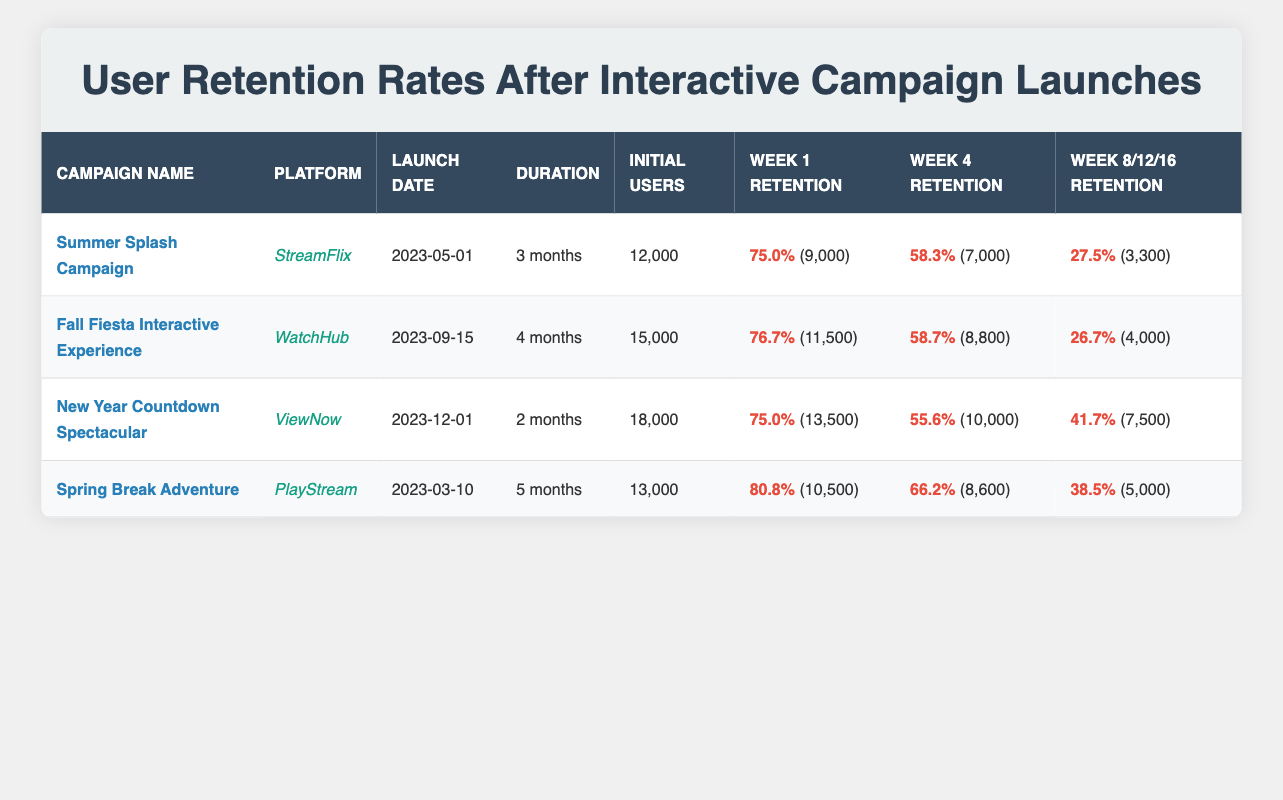What is the retention rate of the Summer Splash Campaign in Week 1? The retention rate for the Summer Splash Campaign in Week 1 is found in the corresponding column and row of the table. It specifically states 75.0%.
Answer: 75.0% How many initial users participated in the Fall Fiesta Interactive Experience? The initial users for the Fall Fiesta Interactive Experience are listed in the 'Initial Users' column, which shows 15,000 users.
Answer: 15,000 What is the difference in Week 4 retention rates between the Spring Break Adventure and the New Year Countdown Spectacular campaigns? The Week 4 retention rate for the Spring Break Adventure is 66.2%, while for the New Year Countdown Spectacular, it is 55.6%. The difference is calculated by subtracting the latter from the former: 66.2% - 55.6% = 10.6%.
Answer: 10.6% Is the retention rate in Week 12 for the Fall Fiesta Interactive Experience higher than that of the Summer Splash Campaign? For the Fall Fiesta campaign, the Week 12 retention rate is 26.7%, while for the Summer Splash campaign, it is 27.5%. Thus, it is true that 26.7% is lower than 27.5%.
Answer: No What is the average retention rate in Week 4 across all campaigns? To find the average retention rate in Week 4, we first list the values: Summer Splash (58.3%), Fall Fiesta (58.7%), New Year Countdown (55.6%), and Spring Break (66.2%). Adding these gives us 58.3 + 58.7 + 55.6 + 66.2 = 238.8. Then, dividing by the number of campaigns (4) gives 238.8 / 4 = 59.7%.
Answer: 59.7% Which campaign had the highest retention rate in Week 1 and what was it? Looking at the Week 1 retention rates for all campaigns: Summer Splash (75.0%), Fall Fiesta (76.7%), New Year Countdown (75.0%), and Spring Break (80.8%). The highest is 80.8% from the Spring Break Adventure.
Answer: Spring Break Adventure, 80.8% What percentage of users were retained after 16 weeks for the Spring Break Adventure campaign? The Spring Break Adventure campaign shows a retention rate of 38.5% after 16 weeks, which is stated in the corresponding column of the table.
Answer: 38.5% Did the New Year Countdown Spectacular campaign retain more users in Week 4 than in Week 1? The New Year Countdown Spectacular retained 13,500 users in Week 1 and 10,000 in Week 4. Therefore, it is false that more users were retained in Week 4 than Week 1.
Answer: No 